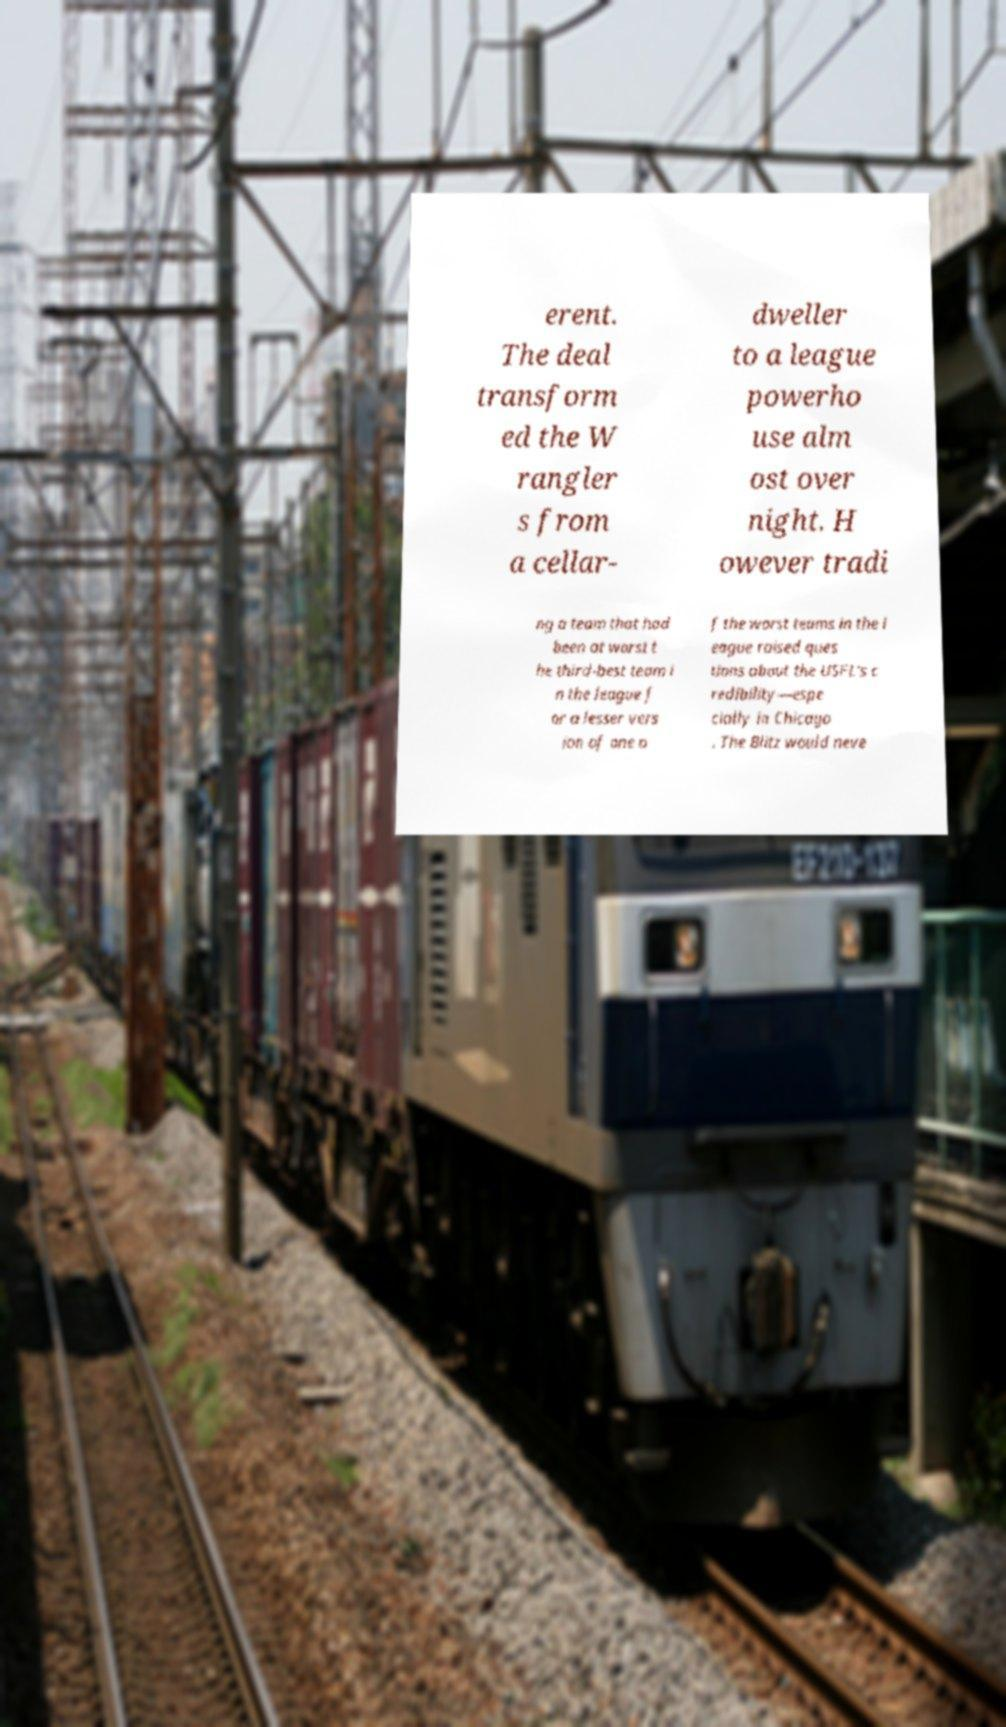I need the written content from this picture converted into text. Can you do that? erent. The deal transform ed the W rangler s from a cellar- dweller to a league powerho use alm ost over night. H owever tradi ng a team that had been at worst t he third-best team i n the league f or a lesser vers ion of one o f the worst teams in the l eague raised ques tions about the USFL's c redibility—espe cially in Chicago . The Blitz would neve 